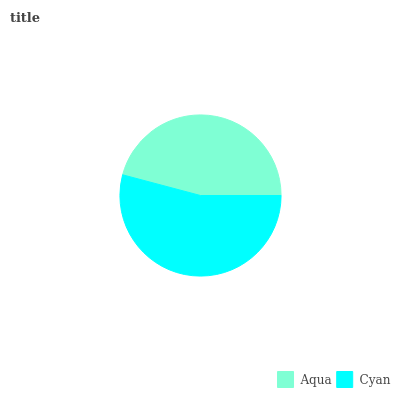Is Aqua the minimum?
Answer yes or no. Yes. Is Cyan the maximum?
Answer yes or no. Yes. Is Cyan the minimum?
Answer yes or no. No. Is Cyan greater than Aqua?
Answer yes or no. Yes. Is Aqua less than Cyan?
Answer yes or no. Yes. Is Aqua greater than Cyan?
Answer yes or no. No. Is Cyan less than Aqua?
Answer yes or no. No. Is Cyan the high median?
Answer yes or no. Yes. Is Aqua the low median?
Answer yes or no. Yes. Is Aqua the high median?
Answer yes or no. No. Is Cyan the low median?
Answer yes or no. No. 